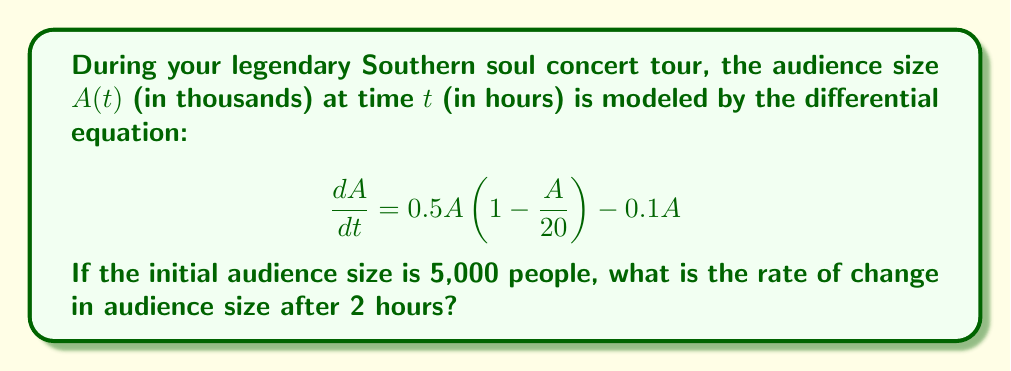Give your solution to this math problem. To solve this problem, we need to follow these steps:

1) First, let's understand the given differential equation:
   $$\frac{dA}{dt} = 0.5A(1 - \frac{A}{20}) - 0.1A$$
   This is a logistic growth model with a decay term.

2) We're asked to find the rate of change after 2 hours, so we need to determine $A(2)$.

3) To find $A(2)$, we need to solve the differential equation. However, this is a complex non-linear equation that doesn't have a simple analytical solution.

4) Given the complexity, we can use Euler's method to approximate $A(2)$:
   $$A(t+\Delta t) \approx A(t) + \Delta t \cdot \frac{dA}{dt}$$

5) Let's use $\Delta t = 0.5$ hours, so we'll calculate four steps:

   At $t=0$: $A(0) = 5$ (given initial condition)
   
   At $t=0.5$: 
   $$A(0.5) \approx 5 + 0.5 \cdot [0.5 \cdot 5(1-\frac{5}{20}) - 0.1 \cdot 5] = 5.625$$
   
   At $t=1$:
   $$A(1) \approx 5.625 + 0.5 \cdot [0.5 \cdot 5.625(1-\frac{5.625}{20}) - 0.1 \cdot 5.625] = 6.289$$
   
   At $t=1.5$:
   $$A(1.5) \approx 6.289 + 0.5 \cdot [0.5 \cdot 6.289(1-\frac{6.289}{20}) - 0.1 \cdot 6.289] = 6.972$$
   
   At $t=2$:
   $$A(2) \approx 6.972 + 0.5 \cdot [0.5 \cdot 6.972(1-\frac{6.972}{20}) - 0.1 \cdot 6.972] = 7.662$$

6) Now that we have $A(2) \approx 7.662$, we can calculate the rate of change at $t=2$:

   $$\frac{dA}{dt}|_{t=2} = 0.5 \cdot 7.662(1 - \frac{7.662}{20}) - 0.1 \cdot 7.662 = 0.668$$

7) Therefore, the rate of change in audience size after 2 hours is approximately 0.668 thousand people per hour, or 668 people per hour.
Answer: The rate of change in audience size after 2 hours is approximately 668 people per hour. 